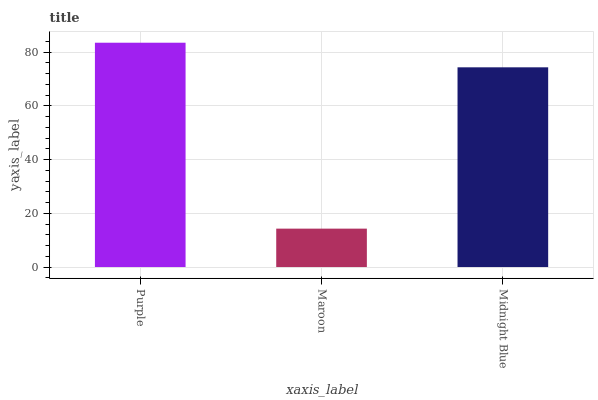Is Maroon the minimum?
Answer yes or no. Yes. Is Purple the maximum?
Answer yes or no. Yes. Is Midnight Blue the minimum?
Answer yes or no. No. Is Midnight Blue the maximum?
Answer yes or no. No. Is Midnight Blue greater than Maroon?
Answer yes or no. Yes. Is Maroon less than Midnight Blue?
Answer yes or no. Yes. Is Maroon greater than Midnight Blue?
Answer yes or no. No. Is Midnight Blue less than Maroon?
Answer yes or no. No. Is Midnight Blue the high median?
Answer yes or no. Yes. Is Midnight Blue the low median?
Answer yes or no. Yes. Is Maroon the high median?
Answer yes or no. No. Is Maroon the low median?
Answer yes or no. No. 